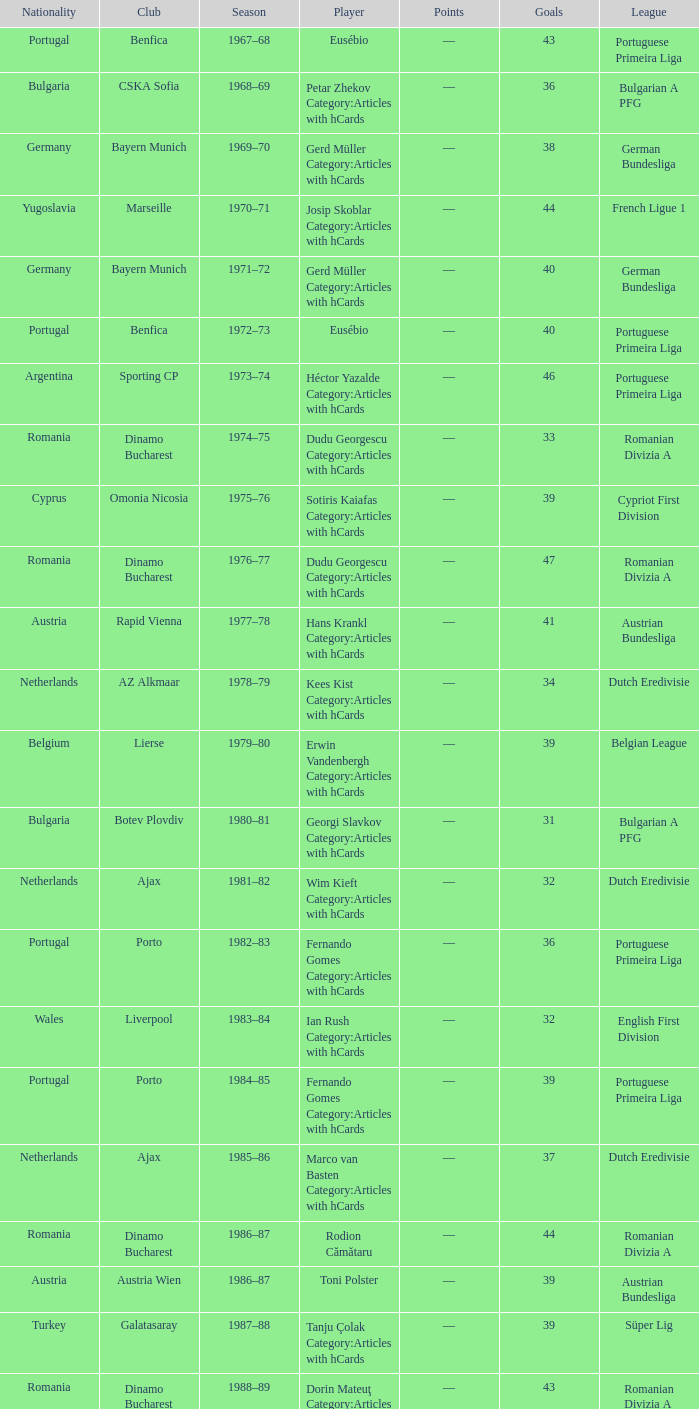Which player was in the Omonia Nicosia club? Sotiris Kaiafas Category:Articles with hCards. 